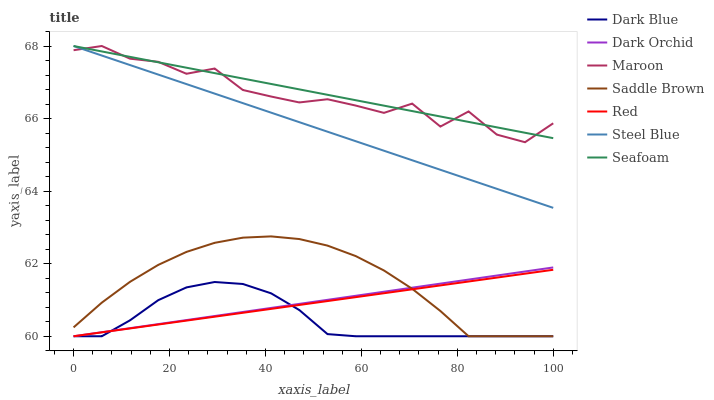Does Maroon have the minimum area under the curve?
Answer yes or no. No. Does Maroon have the maximum area under the curve?
Answer yes or no. No. Is Seafoam the smoothest?
Answer yes or no. No. Is Seafoam the roughest?
Answer yes or no. No. Does Maroon have the lowest value?
Answer yes or no. No. Does Dark Blue have the highest value?
Answer yes or no. No. Is Saddle Brown less than Seafoam?
Answer yes or no. Yes. Is Seafoam greater than Red?
Answer yes or no. Yes. Does Saddle Brown intersect Seafoam?
Answer yes or no. No. 